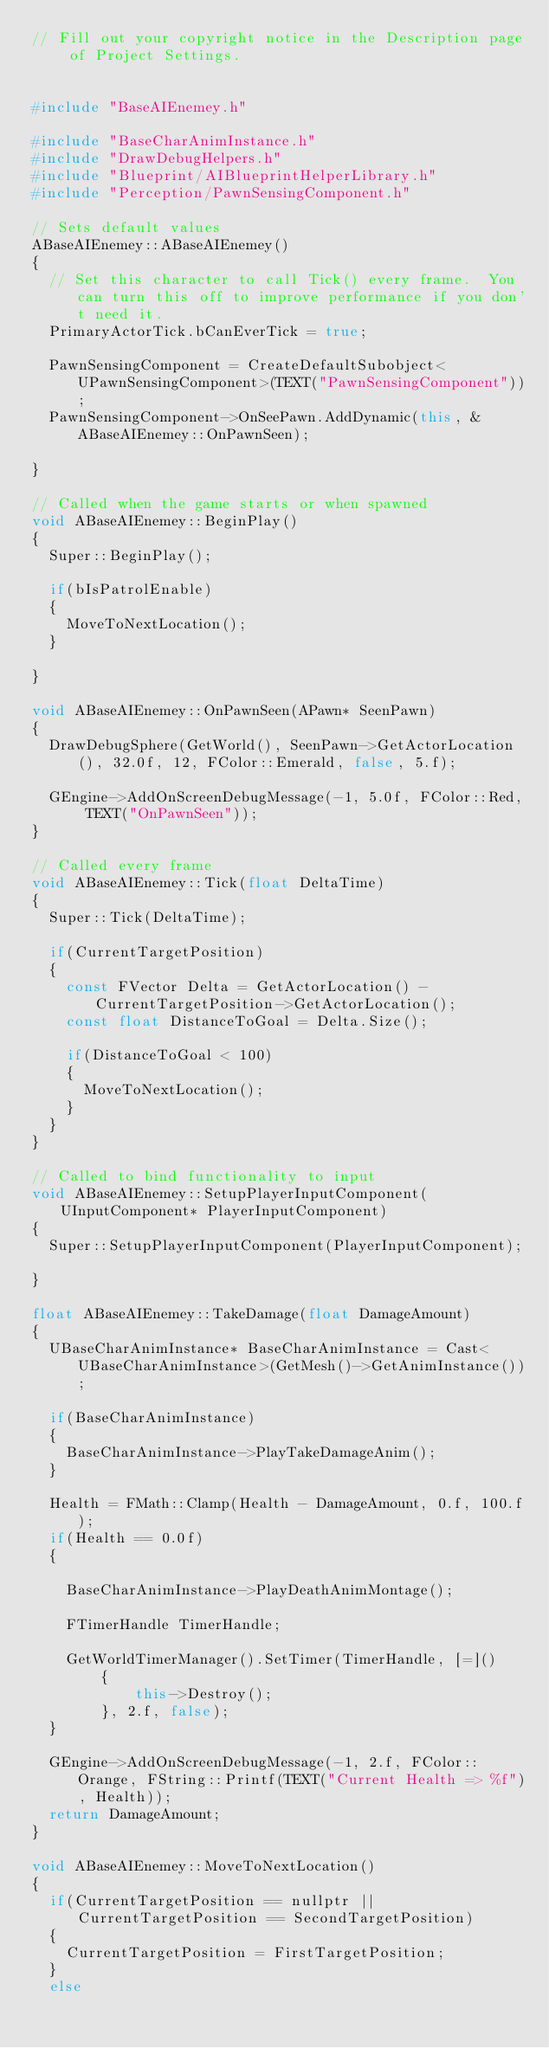Convert code to text. <code><loc_0><loc_0><loc_500><loc_500><_C++_>// Fill out your copyright notice in the Description page of Project Settings.


#include "BaseAIEnemey.h"

#include "BaseCharAnimInstance.h"
#include "DrawDebugHelpers.h"
#include "Blueprint/AIBlueprintHelperLibrary.h"
#include "Perception/PawnSensingComponent.h"

// Sets default values
ABaseAIEnemey::ABaseAIEnemey()
{
 	// Set this character to call Tick() every frame.  You can turn this off to improve performance if you don't need it.
	PrimaryActorTick.bCanEverTick = true;

	PawnSensingComponent = CreateDefaultSubobject<UPawnSensingComponent>(TEXT("PawnSensingComponent"));
	PawnSensingComponent->OnSeePawn.AddDynamic(this, &ABaseAIEnemey::OnPawnSeen);

}

// Called when the game starts or when spawned
void ABaseAIEnemey::BeginPlay()
{
	Super::BeginPlay();

	if(bIsPatrolEnable)
	{
		MoveToNextLocation();
	}
	
}

void ABaseAIEnemey::OnPawnSeen(APawn* SeenPawn)
{
	DrawDebugSphere(GetWorld(), SeenPawn->GetActorLocation(), 32.0f, 12, FColor::Emerald, false, 5.f);

	GEngine->AddOnScreenDebugMessage(-1, 5.0f, FColor::Red, TEXT("OnPawnSeen"));
}

// Called every frame
void ABaseAIEnemey::Tick(float DeltaTime)
{
	Super::Tick(DeltaTime);

	if(CurrentTargetPosition)
	{
		const FVector Delta = GetActorLocation() - CurrentTargetPosition->GetActorLocation();
		const float DistanceToGoal = Delta.Size();

		if(DistanceToGoal < 100)
		{
			MoveToNextLocation();
		}
	}
}

// Called to bind functionality to input
void ABaseAIEnemey::SetupPlayerInputComponent(UInputComponent* PlayerInputComponent)
{
	Super::SetupPlayerInputComponent(PlayerInputComponent);

}

float ABaseAIEnemey::TakeDamage(float DamageAmount)
{
	UBaseCharAnimInstance* BaseCharAnimInstance = Cast<UBaseCharAnimInstance>(GetMesh()->GetAnimInstance());

	if(BaseCharAnimInstance)
	{
		BaseCharAnimInstance->PlayTakeDamageAnim();
	}
	
	Health = FMath::Clamp(Health - DamageAmount, 0.f, 100.f);
	if(Health == 0.0f)
	{
		
		BaseCharAnimInstance->PlayDeathAnimMontage();

		FTimerHandle TimerHandle;

		GetWorldTimerManager().SetTimer(TimerHandle, [=]()
        {
            this->Destroy();
        }, 2.f, false);
	}
	
	GEngine->AddOnScreenDebugMessage(-1, 2.f, FColor::Orange, FString::Printf(TEXT("Current Health => %f"), Health));
	return DamageAmount;
}

void ABaseAIEnemey::MoveToNextLocation()
{	
	if(CurrentTargetPosition == nullptr || CurrentTargetPosition == SecondTargetPosition)
	{
		CurrentTargetPosition = FirstTargetPosition;
	}
	else</code> 